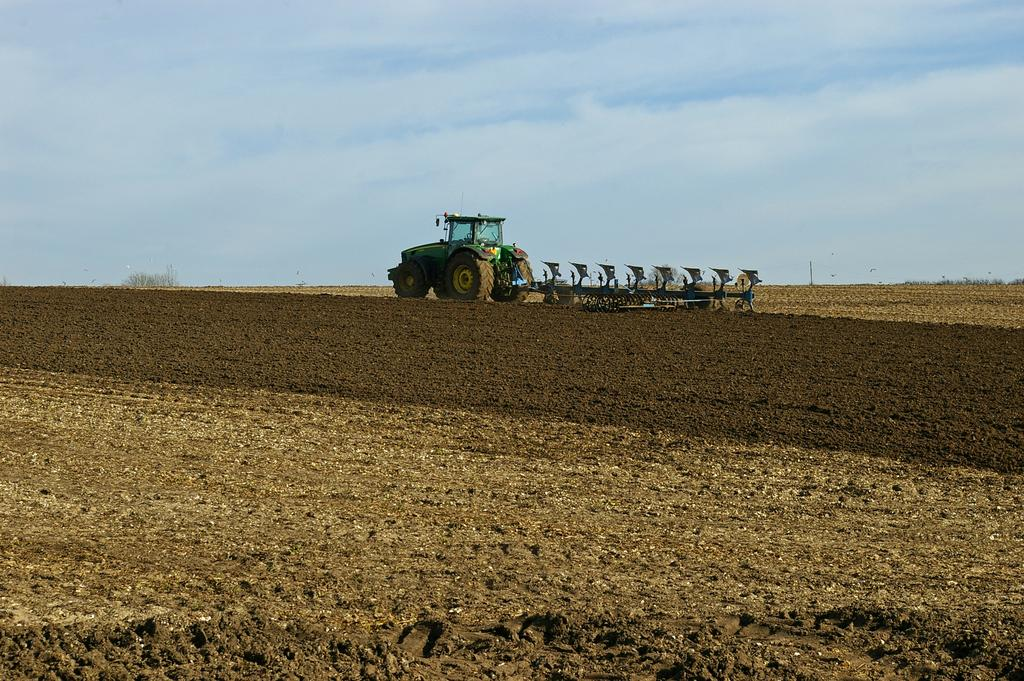What is the main subject of the picture? The main subject of the picture is a tractor. Is there anything attached to the tractor? Yes, there is an object attached to the tractor. What can be seen in the background of the picture? There are trees and the sky visible in the background of the picture. What type of hobbies can be seen being practiced in the quicksand in the image? There is no quicksand or any hobbies being practiced in the image; it features a tractor with an attached object and a background of trees and sky. 